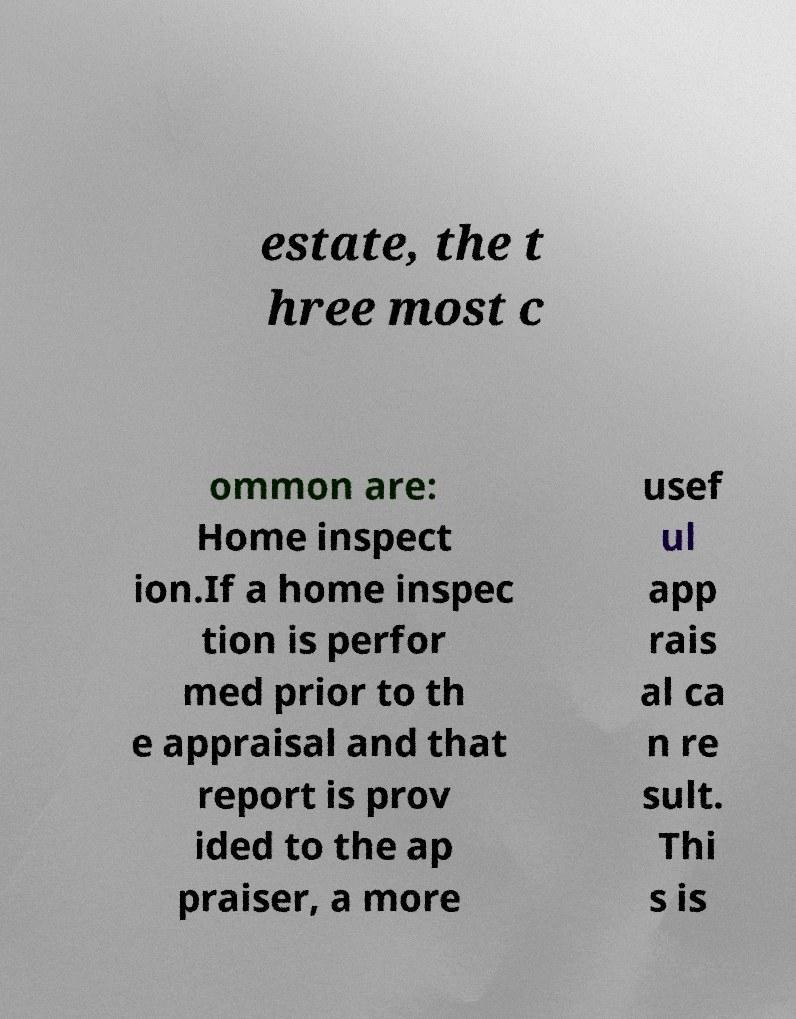Can you accurately transcribe the text from the provided image for me? estate, the t hree most c ommon are: Home inspect ion.If a home inspec tion is perfor med prior to th e appraisal and that report is prov ided to the ap praiser, a more usef ul app rais al ca n re sult. Thi s is 